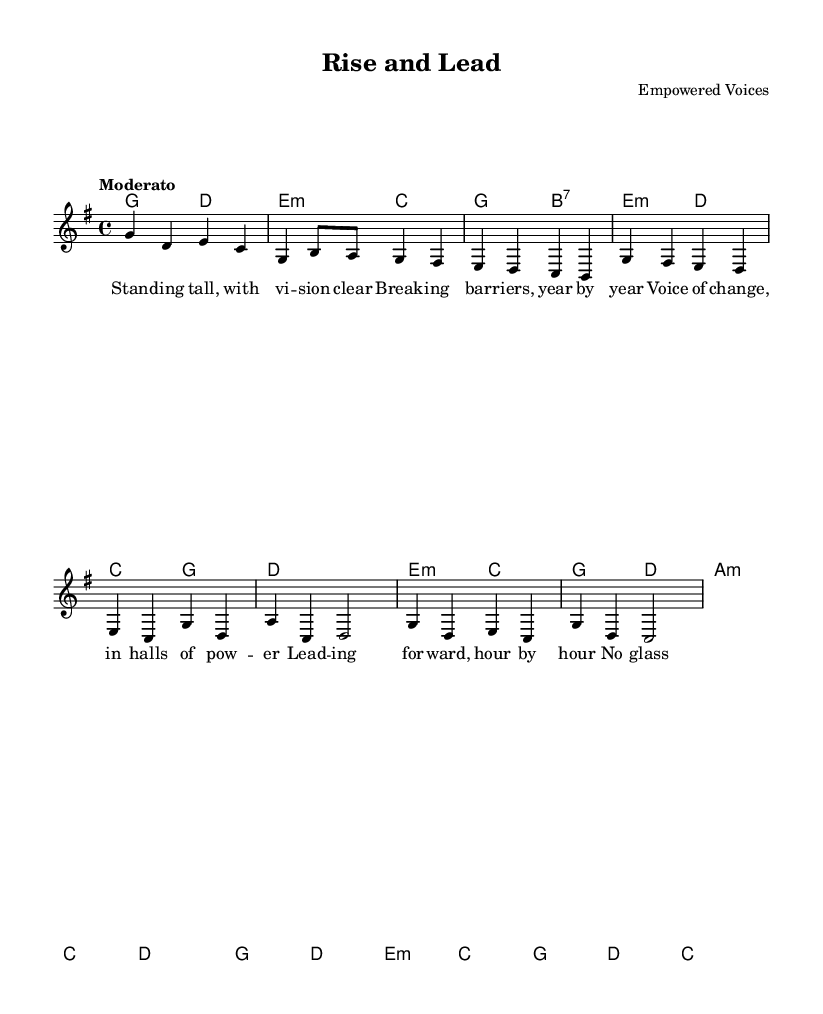What is the key signature of this music? The key signature is identified by the sharp or flat symbols at the beginning of the staff. In this music, there are no sharps or flats indicated, which signifies that it is in G major.
Answer: G major What is the time signature of this music? The time signature is located at the beginning of the piece, indicating how many beats are in each measure. Here, the time signature is 4/4, meaning there are four beats per measure.
Answer: 4/4 What is the tempo marking for this music? The tempo marking, which indicates the speed of the piece, is written in Italian above the staff. In this case, it says "Moderato," suggesting a moderate speed.
Answer: Moderato How many measures are there in the chorus section? To determine the number of measures in the chorus, one counts each segment of music that is separated by vertical lines. The chorus consists of four measures.
Answer: Four What is the main theme of the lyrics presented in this music? Analyzing the lyrics will reveal their thematic focus. The lyrics discuss empowerment, unity, and leadership among women, which is central to the song's message.
Answer: Empowerment What chord is played during the pre-chorus section? The chords for each section are written as part of the harmonies. During the pre-chorus, the chord progression includes E minor and C major, indicative of a shift in energy towards the chorus.
Answer: E minor 